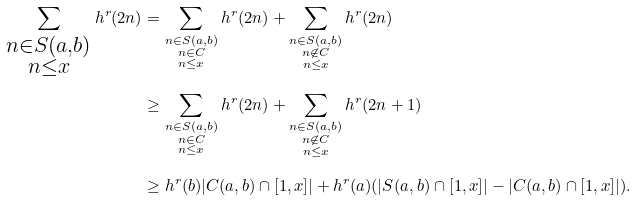<formula> <loc_0><loc_0><loc_500><loc_500>\sum _ { \substack { n \in S ( a , b ) \\ n \leq x } } h ^ { r } ( 2 n ) & = \sum _ { \substack { n \in S ( a , b ) \\ n \in C \\ n \leq x } } h ^ { r } ( 2 n ) + \sum _ { \substack { n \in S ( a , b ) \\ n \not \in C \\ n \leq x } } h ^ { r } ( 2 n ) \\ & \geq \sum _ { \substack { n \in S ( a , b ) \\ n \in C \\ n \leq x } } h ^ { r } ( 2 n ) + \sum _ { \substack { n \in S ( a , b ) \\ n \not \in C \\ n \leq x } } h ^ { r } ( 2 n + 1 ) \\ & \geq h ^ { r } ( b ) | C ( a , b ) \cap [ 1 , x ] | + h ^ { r } ( a ) ( | S ( a , b ) \cap [ 1 , x ] | - | C ( a , b ) \cap [ 1 , x ] | ) .</formula> 